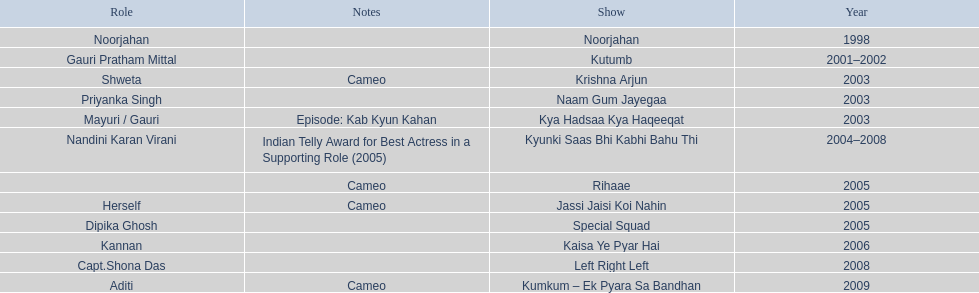What are all of the shows? Noorjahan, Kutumb, Krishna Arjun, Naam Gum Jayegaa, Kya Hadsaa Kya Haqeeqat, Kyunki Saas Bhi Kabhi Bahu Thi, Rihaae, Jassi Jaisi Koi Nahin, Special Squad, Kaisa Ye Pyar Hai, Left Right Left, Kumkum – Ek Pyara Sa Bandhan. When did they premiere? 1998, 2001–2002, 2003, 2003, 2003, 2004–2008, 2005, 2005, 2005, 2006, 2008, 2009. What notes are there for the shows from 2005? Cameo, Cameo. Help me parse the entirety of this table. {'header': ['Role', 'Notes', 'Show', 'Year'], 'rows': [['Noorjahan', '', 'Noorjahan', '1998'], ['Gauri Pratham Mittal', '', 'Kutumb', '2001–2002'], ['Shweta', 'Cameo', 'Krishna Arjun', '2003'], ['Priyanka Singh', '', 'Naam Gum Jayegaa', '2003'], ['Mayuri / Gauri', 'Episode: Kab Kyun Kahan', 'Kya Hadsaa Kya Haqeeqat', '2003'], ['Nandini Karan Virani', 'Indian Telly Award for Best Actress in a Supporting Role (2005)', 'Kyunki Saas Bhi Kabhi Bahu Thi', '2004–2008'], ['', 'Cameo', 'Rihaae', '2005'], ['Herself', 'Cameo', 'Jassi Jaisi Koi Nahin', '2005'], ['Dipika Ghosh', '', 'Special Squad', '2005'], ['Kannan', '', 'Kaisa Ye Pyar Hai', '2006'], ['Capt.Shona Das', '', 'Left Right Left', '2008'], ['Aditi', 'Cameo', 'Kumkum – Ek Pyara Sa Bandhan', '2009']]} Along with rihaee, what is the other show gauri had a cameo role in? Jassi Jaisi Koi Nahin. 